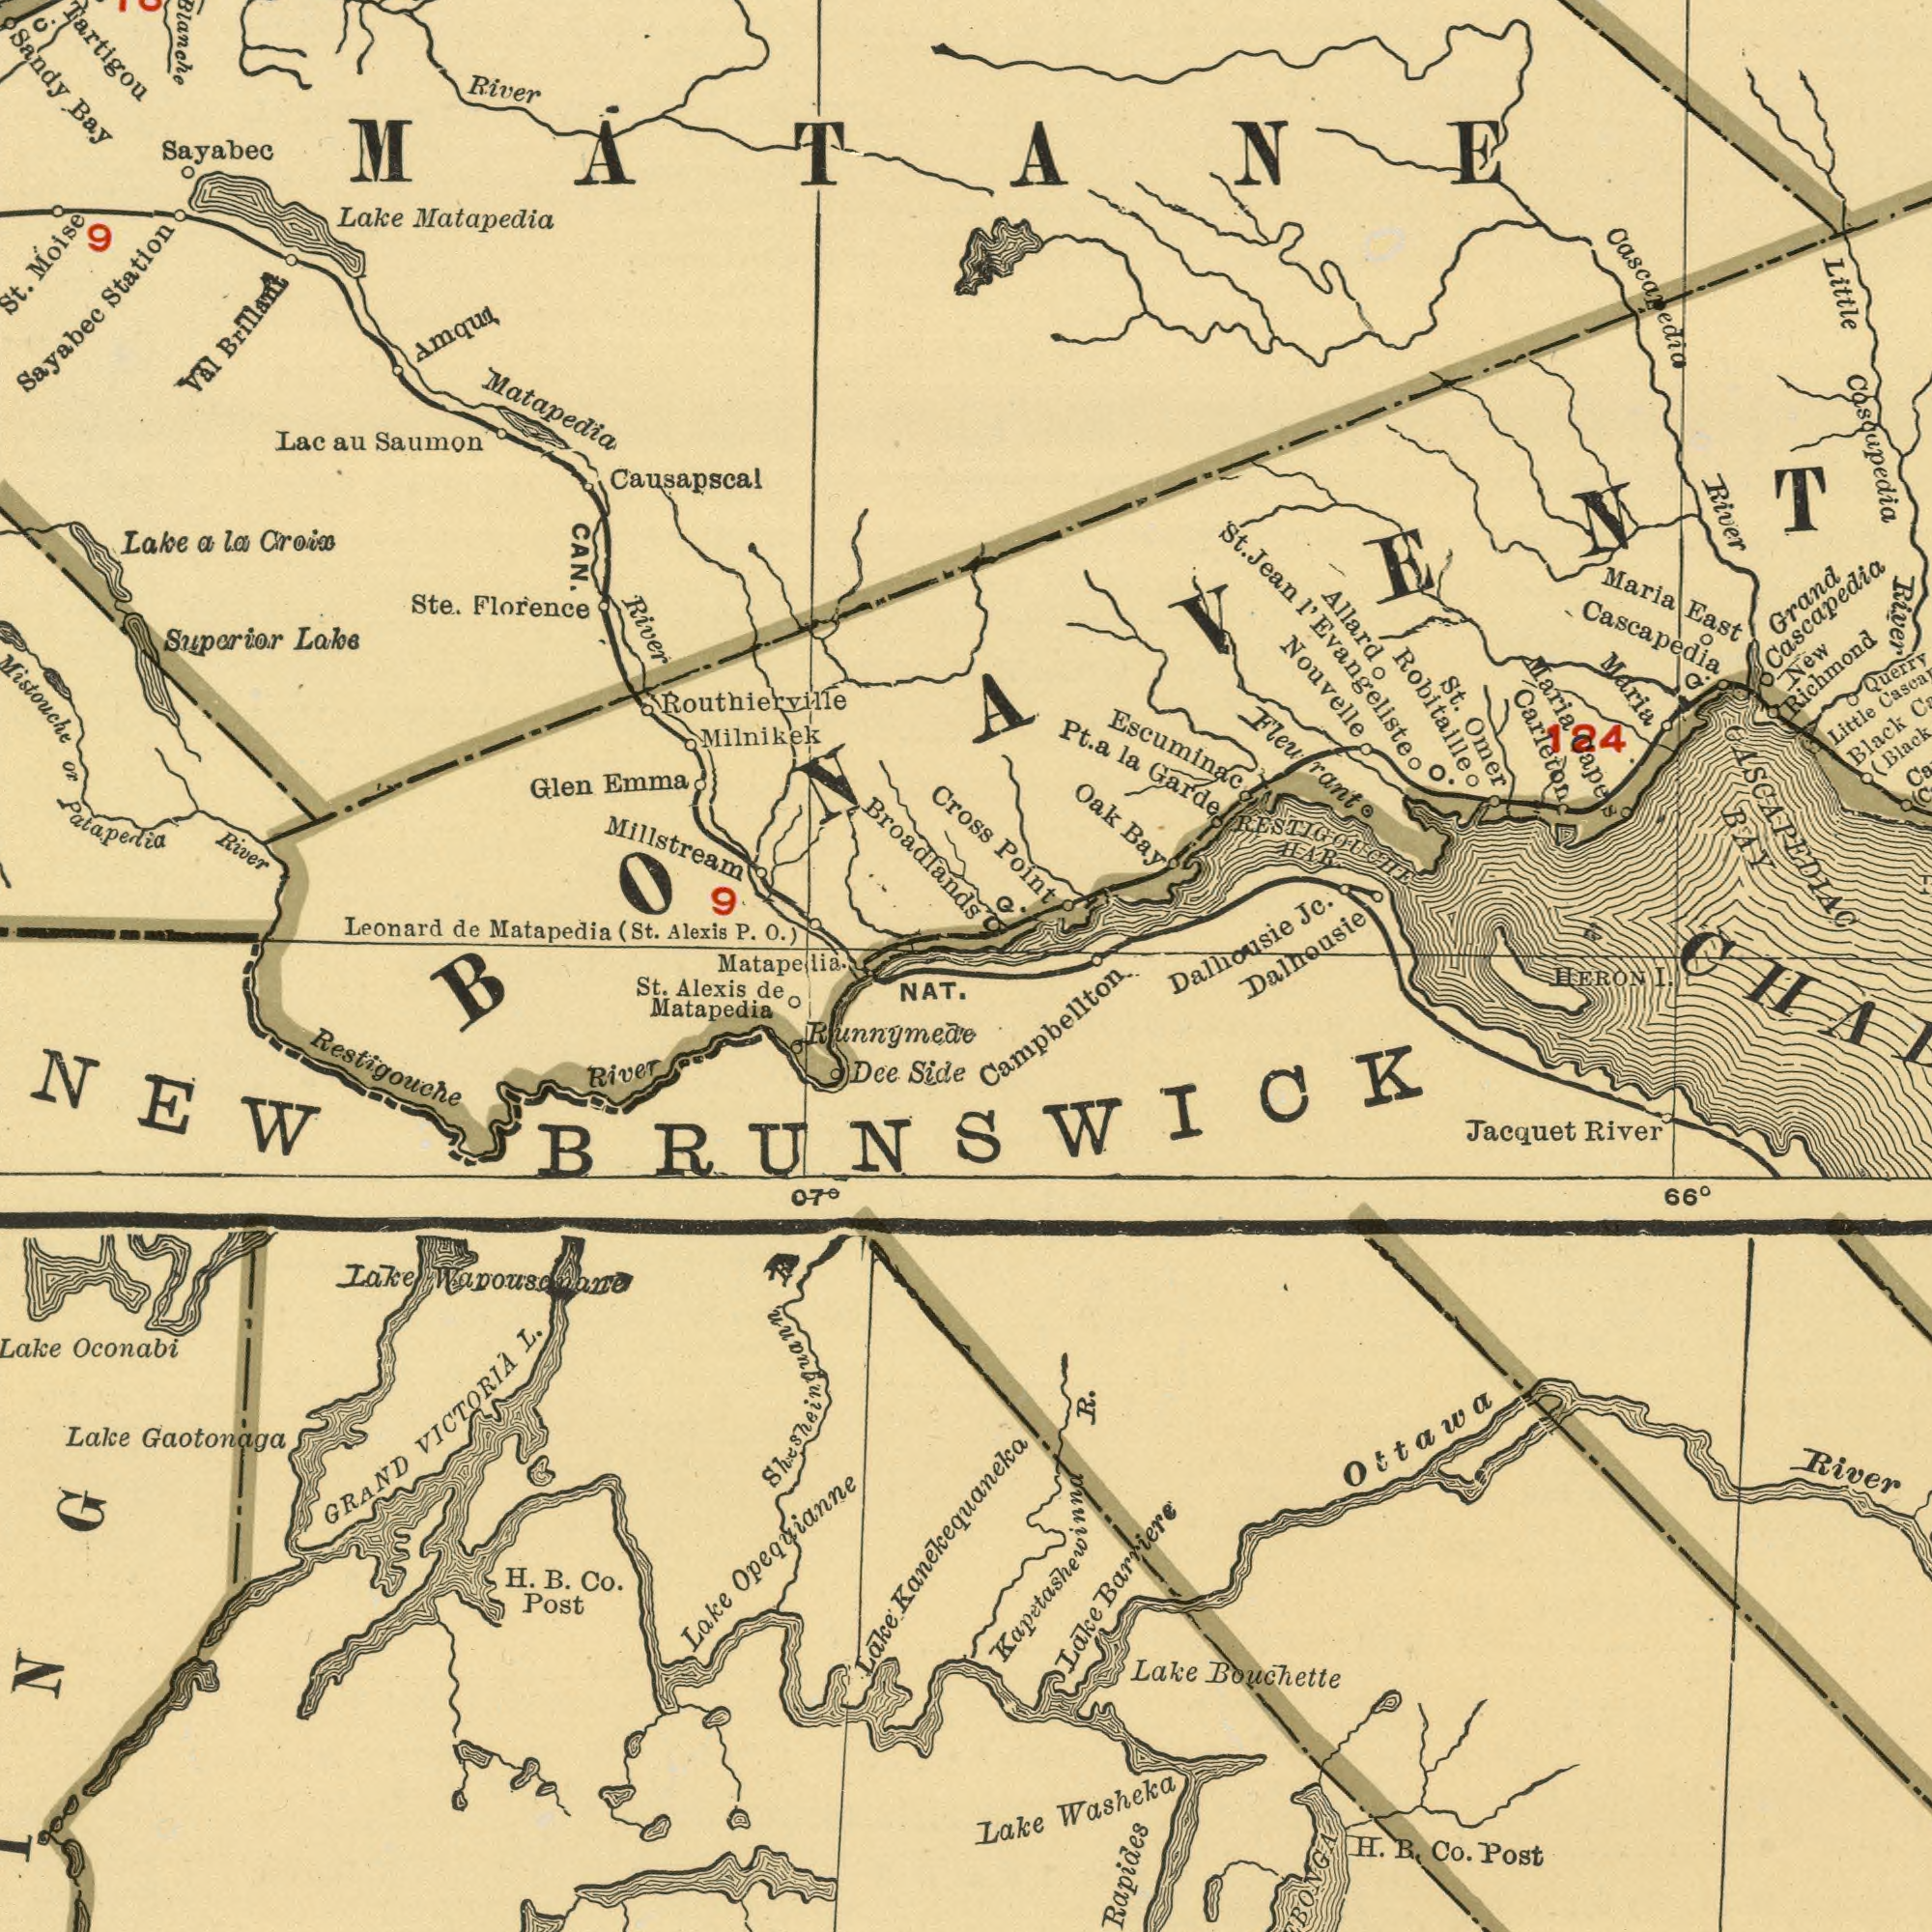What text is shown in the bottom-left quadrant? Restigouche VICTORIA Gaotonaga Matapedia GRAND Dee Oconabi Lake Lake St. Lake NAT. Post Co. Opequianne Lake B. Runnymede 07<sup>0</sup> Lake River Alexis de R. H. L. Shesheinguann Side Wapousonane NEW What text is shown in the bottom-right quadrant? Kanekequaneka Washeka R. Bouchette Rapides Lake River Lake Ottawa B. Post Co. River Jacquet H. HERON 66<sup>0</sup> Lake Barriere Campbellton Kapetashewinna I. BRUNSWICK What text can you see in the top-right section? Cascapedia Nouvelle Escuminac Point Carleton Cascapedia BAY Jc. Robitaille Maria East Oak Allard Pt. St. Black Little River Little River HAR. Richmond Grand OASCAPEDIAC Maria Evangeliste Bay St. 124 New Omer Garde Cascapedia Maria la O. Capes RESTIGOUCHE Cascapedia Fleurant Cross a Q. Dalhousie Dalhousie Jena I' Q. What text is shown in the top-left quadrant? Causapscal Broadlands Matapedia Leonard Milnikek Sayabec Matapedia Station River Saumon CAN. River Sayabec Bay Matapedia Emma Lake St. Blanche or Brillant Suparior (St. Millstream Croix Tartigou Alexis Lake Lake Glen Routhierville Ste. la O.) Val Lac Florence P. Moise au a de C. Sandy 9 River Patapedia MATANE 9 Matapelia. 